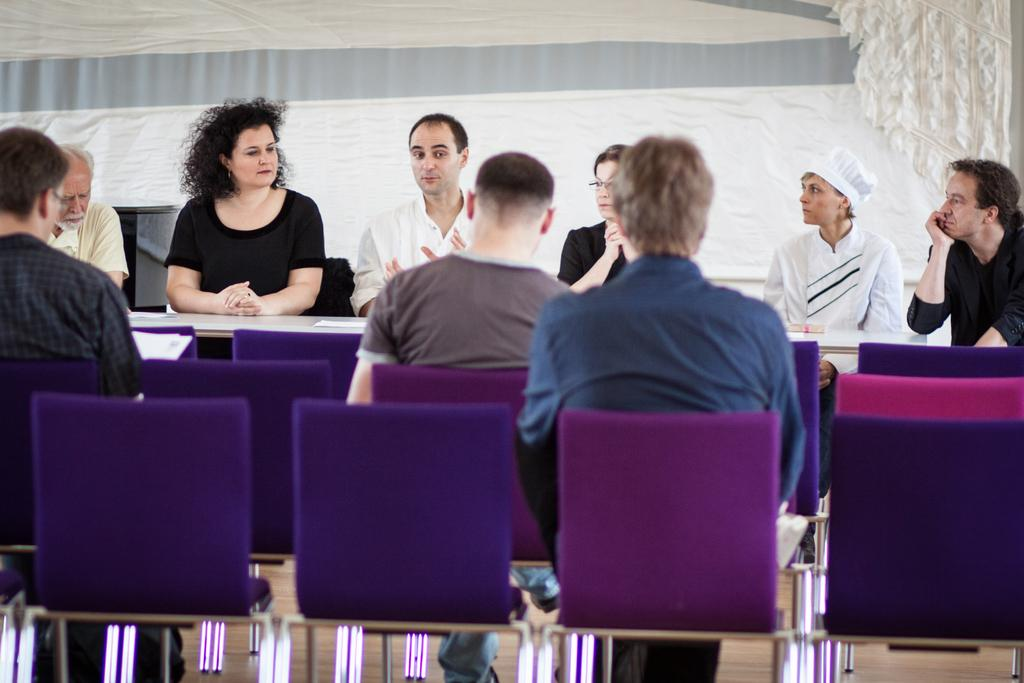What is the main subject of the image? The main subject of the image is a group of people. What are the people in the image doing? The people are seated on chairs. What type of fruit is being served on the playground in the image? There is no fruit or playground present in the image; it features a group of people seated on chairs. 